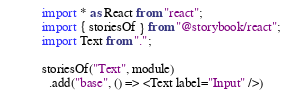Convert code to text. <code><loc_0><loc_0><loc_500><loc_500><_JavaScript_>import * as React from "react";
import { storiesOf } from "@storybook/react";
import Text from ".";

storiesOf("Text", module)
  .add("base", () => <Text label="Input" />)
</code> 